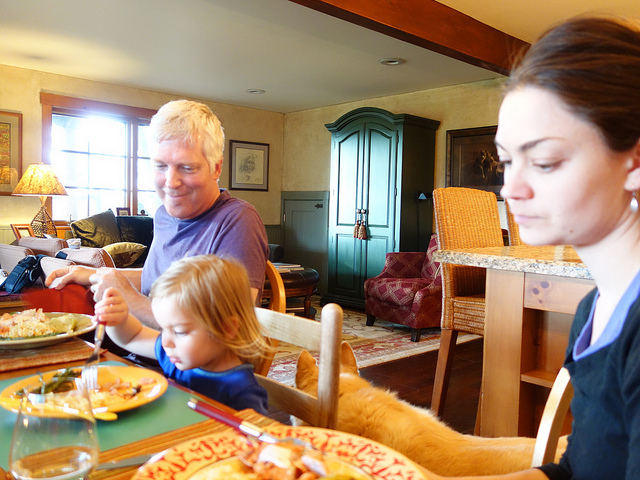What can you deduce about the family's relationship from this image? While it's not appropriate to make detailed assumptions about personal relationships from a single image, the scene might imply a sense of closeness and family bonding. The individuals are seated together at the table, sharing a meal, which often indicates a moment of communion and shared experiences in many cultures. 